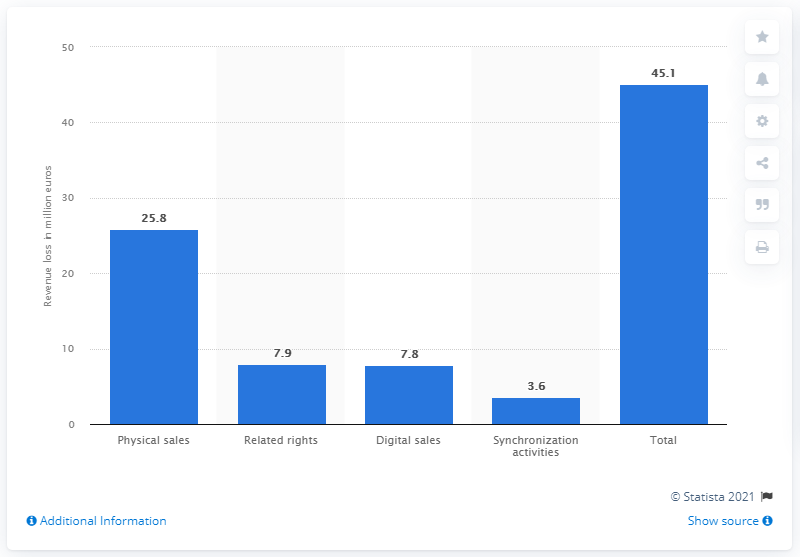Mention a couple of crucial points in this snapshot. Physical sales fell by 25.8% in the given period. 